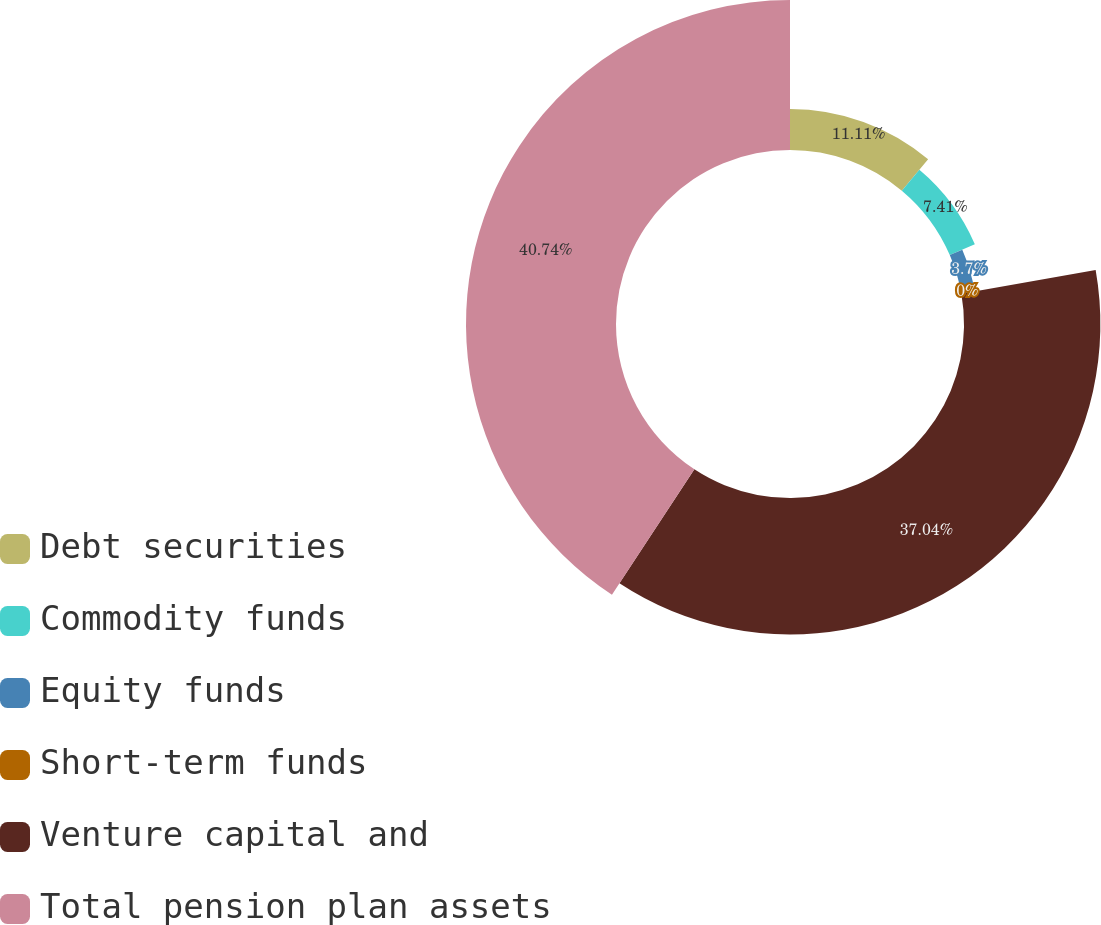Convert chart to OTSL. <chart><loc_0><loc_0><loc_500><loc_500><pie_chart><fcel>Debt securities<fcel>Commodity funds<fcel>Equity funds<fcel>Short-term funds<fcel>Venture capital and<fcel>Total pension plan assets<nl><fcel>11.11%<fcel>7.41%<fcel>3.7%<fcel>0.0%<fcel>37.04%<fcel>40.74%<nl></chart> 